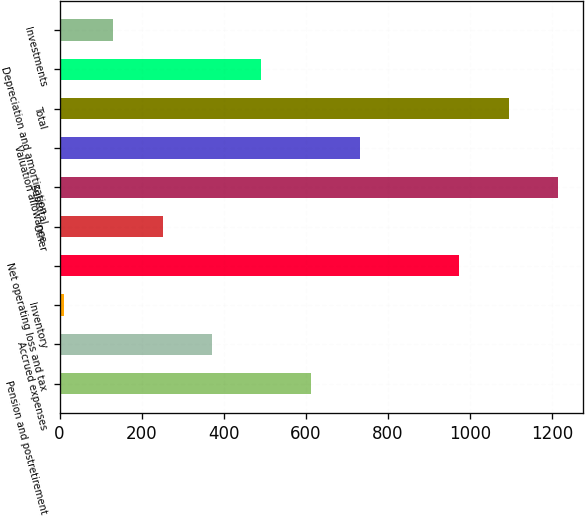Convert chart. <chart><loc_0><loc_0><loc_500><loc_500><bar_chart><fcel>Pension and postretirement<fcel>Accrued expenses<fcel>Inventory<fcel>Net operating loss and tax<fcel>Other<fcel>Subtotal<fcel>Valuation allowance<fcel>Total<fcel>Depreciation and amortization<fcel>Investments<nl><fcel>612<fcel>371.2<fcel>10<fcel>973.2<fcel>250.8<fcel>1214<fcel>732.4<fcel>1093.6<fcel>491.6<fcel>130.4<nl></chart> 